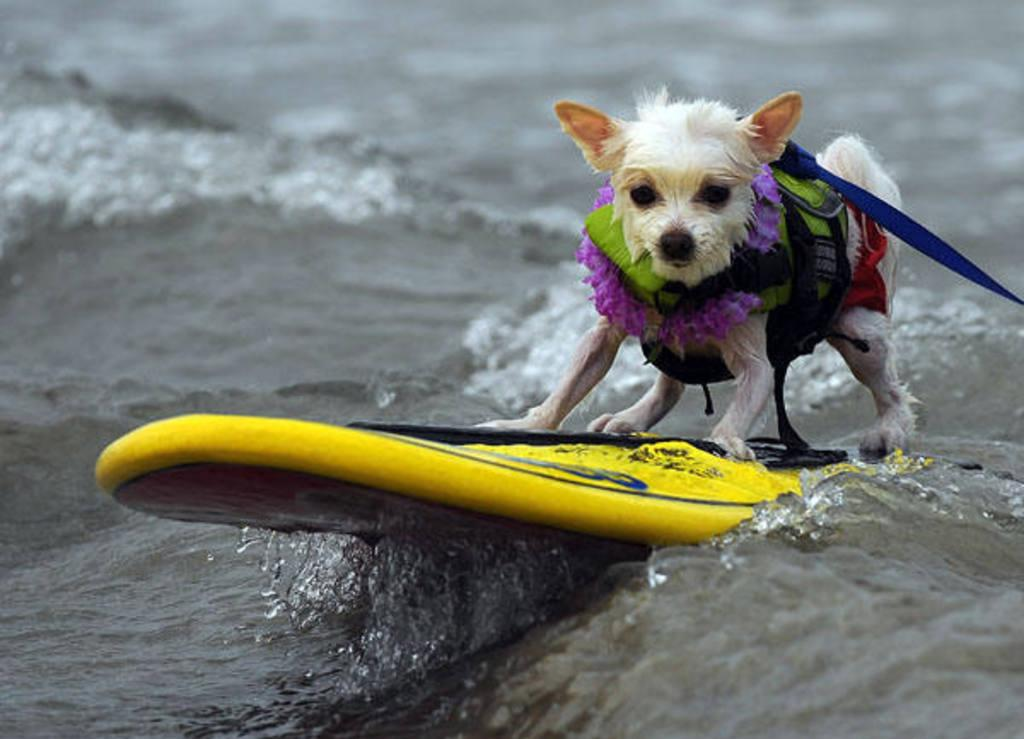What type of animal is present in the image? There is a dog in the image. What is the dog wearing in the image? The dog is wearing a belt in the image. What object can be seen in the image besides the dog? There is a board in the image. What is the board's position in relation to the water? The board is placed in water in the image. What type of wealth can be seen in the image? There is no wealth present in the image. What type of leaf can be seen falling from the tree in the image? There is no tree or leaf present in the image. 